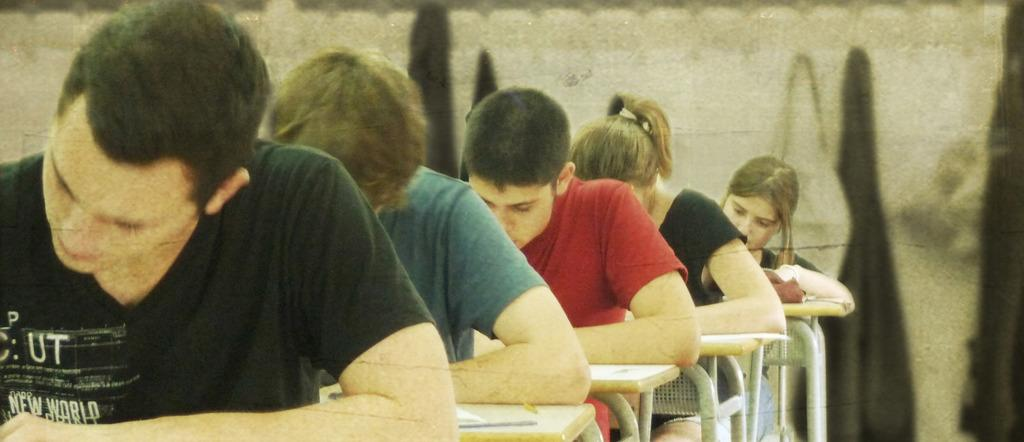What are the people in the image doing? The people in the image are sitting on a table. What can be seen in the background of the image? There is a wall in the background of the image. What type of horn can be seen on the table in the image? There is no horn present on the table in the image. 